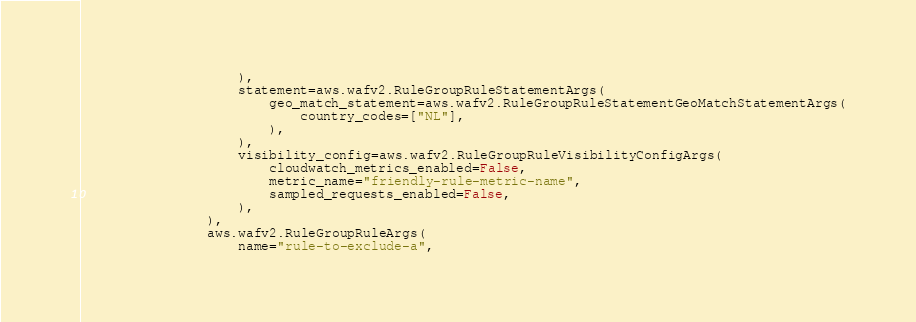Convert code to text. <code><loc_0><loc_0><loc_500><loc_500><_Python_>                    ),
                    statement=aws.wafv2.RuleGroupRuleStatementArgs(
                        geo_match_statement=aws.wafv2.RuleGroupRuleStatementGeoMatchStatementArgs(
                            country_codes=["NL"],
                        ),
                    ),
                    visibility_config=aws.wafv2.RuleGroupRuleVisibilityConfigArgs(
                        cloudwatch_metrics_enabled=False,
                        metric_name="friendly-rule-metric-name",
                        sampled_requests_enabled=False,
                    ),
                ),
                aws.wafv2.RuleGroupRuleArgs(
                    name="rule-to-exclude-a",</code> 